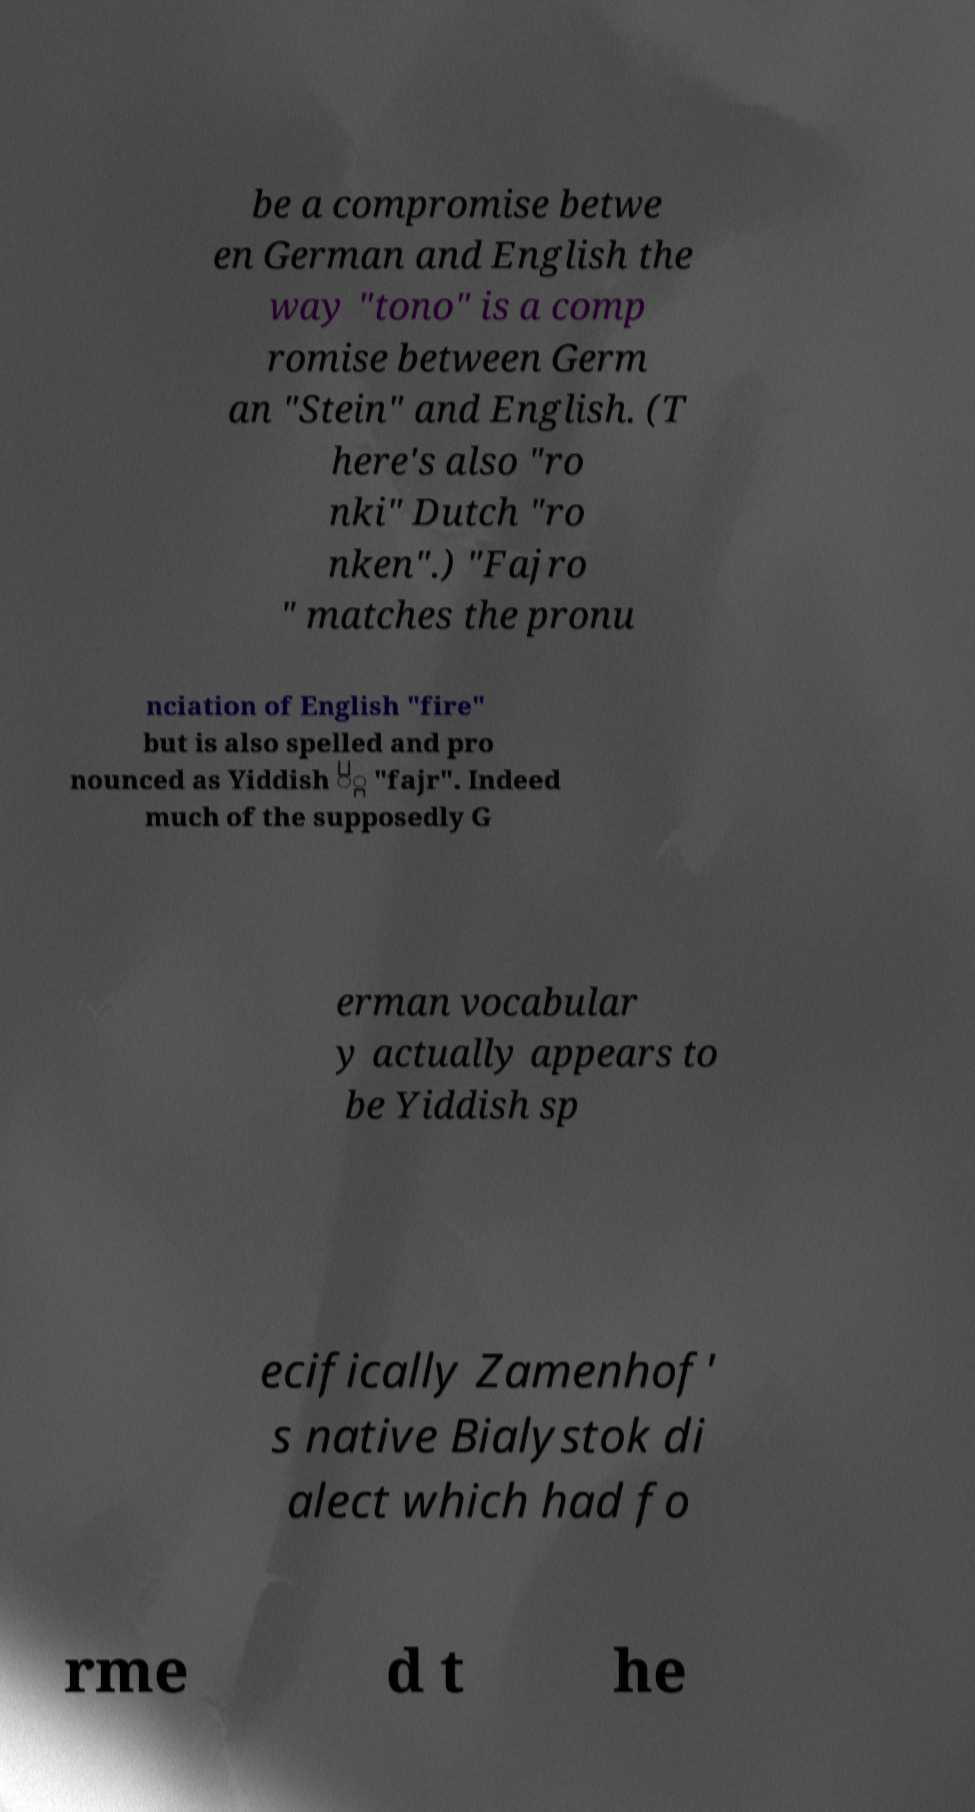Could you assist in decoding the text presented in this image and type it out clearly? be a compromise betwe en German and English the way "tono" is a comp romise between Germ an "Stein" and English. (T here's also "ro nki" Dutch "ro nken".) "Fajro " matches the pronu nciation of English "fire" but is also spelled and pro nounced as Yiddish ַֿ "fajr". Indeed much of the supposedly G erman vocabular y actually appears to be Yiddish sp ecifically Zamenhof' s native Bialystok di alect which had fo rme d t he 